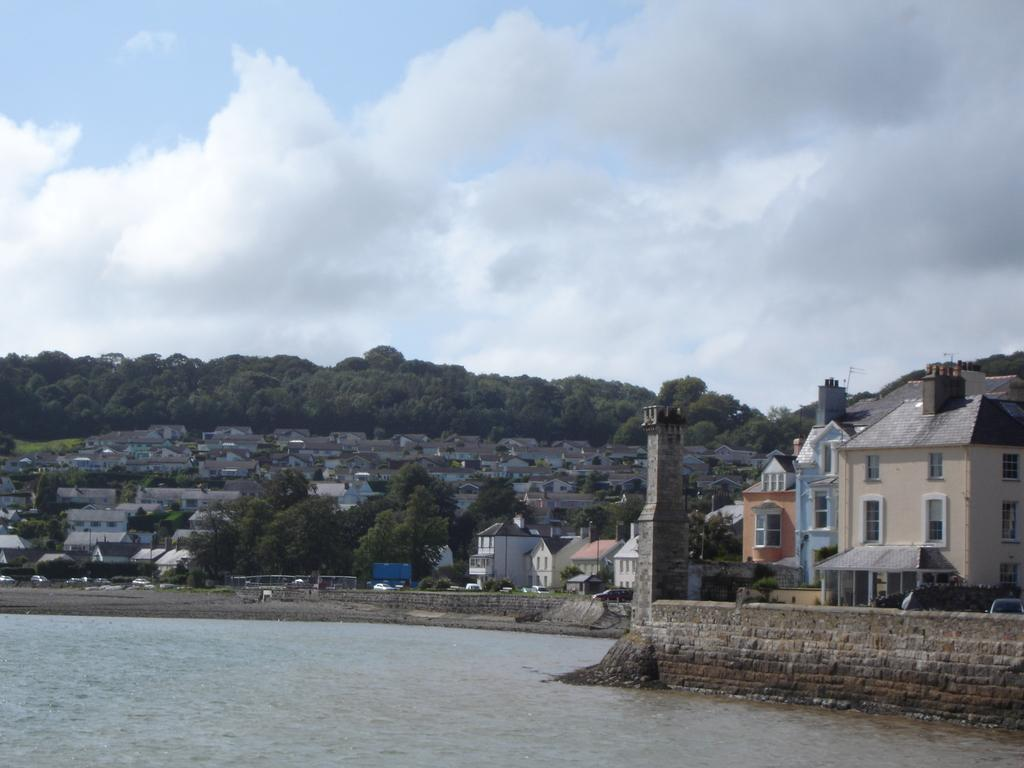What is the primary element visible in the image? There is water in the image. What structures can be seen in the image? There are buildings in the image. What type of vegetation is present in the image? There are trees in the image. What is visible at the top of the image? The sky is visible at the top of the image. What can be observed in the sky? There are clouds in the sky. What type of treatment is being administered to the friend in the image? There is no friend or treatment present in the image; it features water, buildings, trees, and clouds in the sky. 